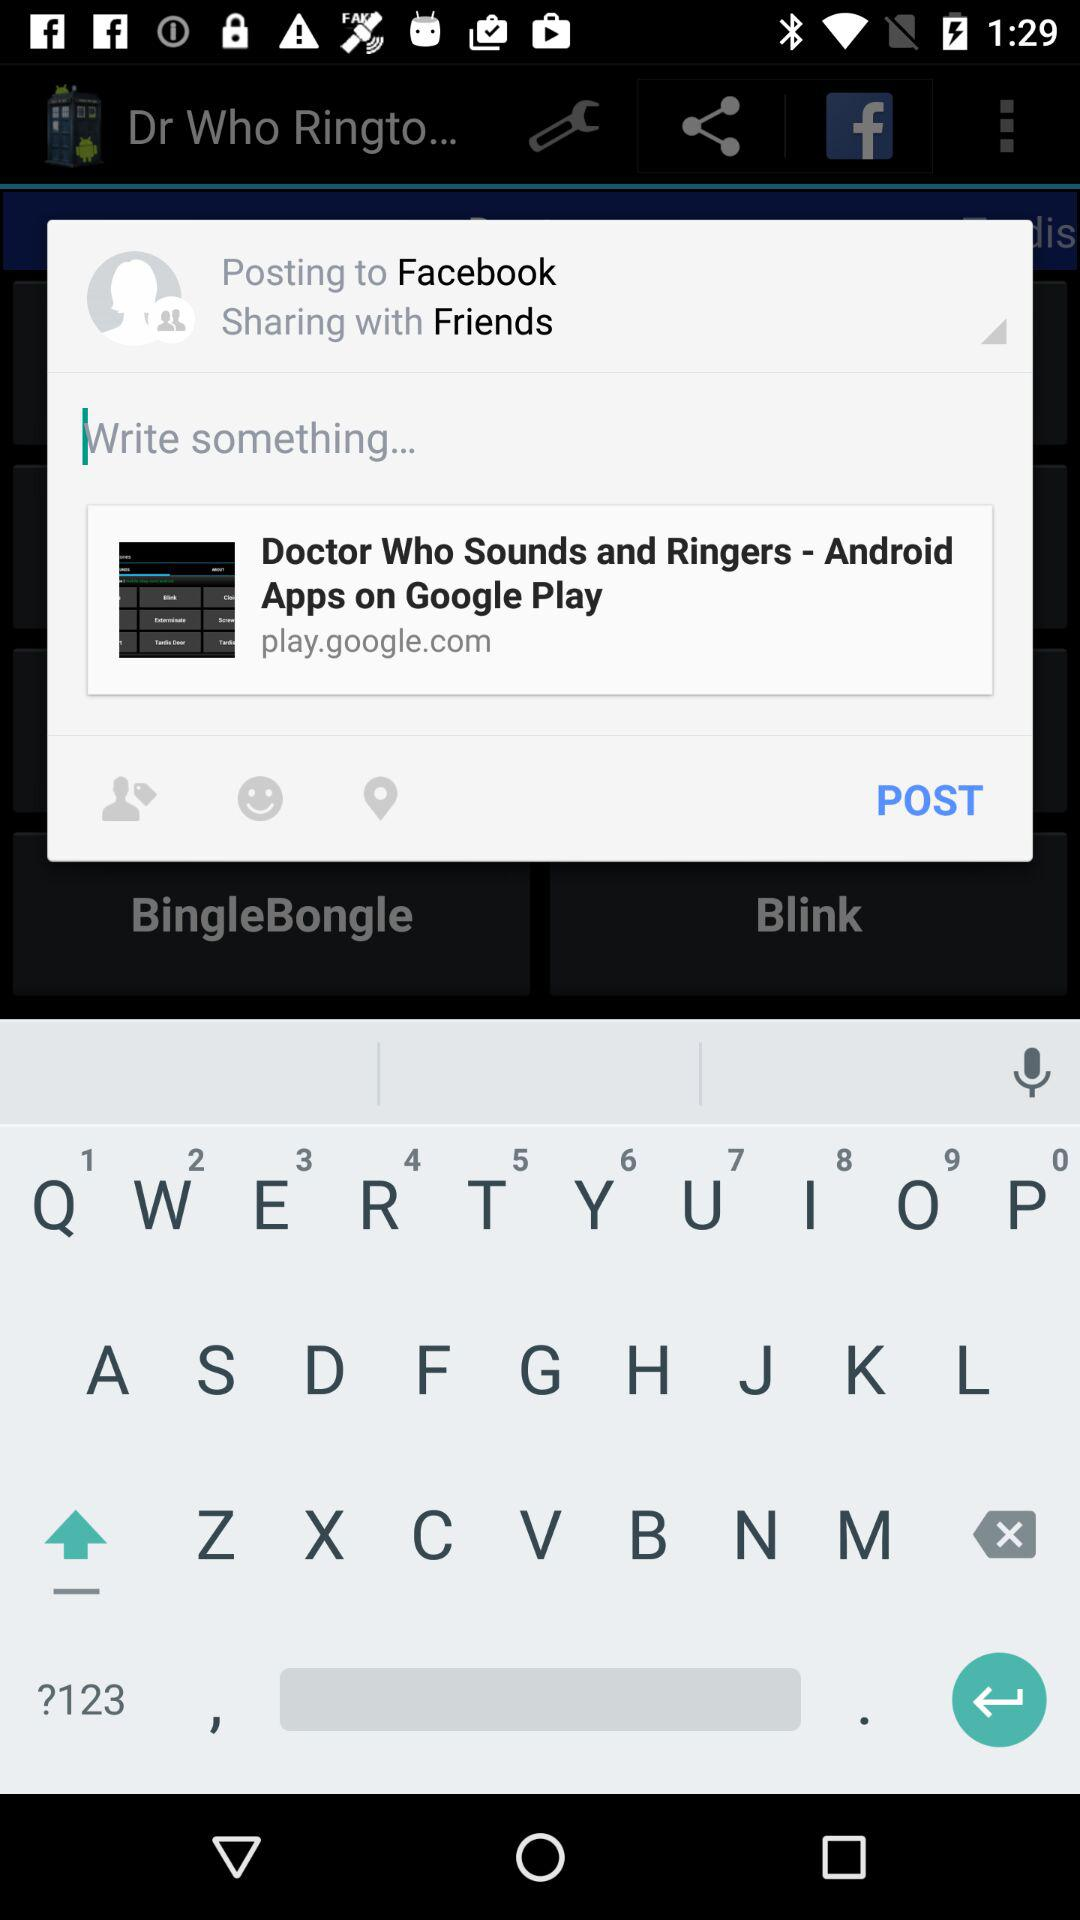How much does the Doctor Who application cost?
When the provided information is insufficient, respond with <no answer>. <no answer> 